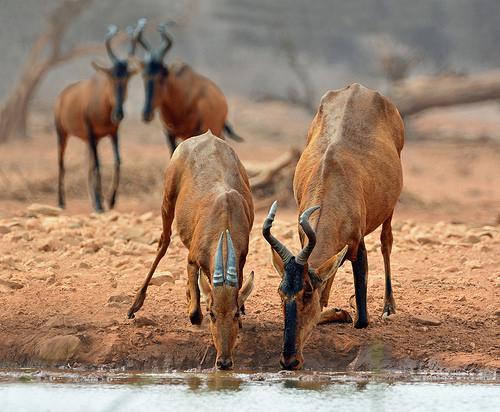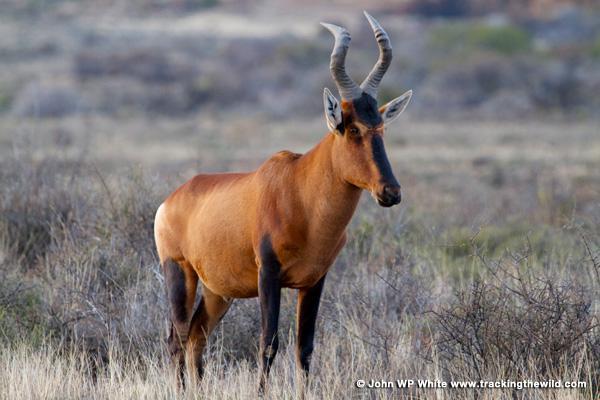The first image is the image on the left, the second image is the image on the right. For the images displayed, is the sentence "There are exactly two horned animals standing in total." factually correct? Answer yes or no. No. The first image is the image on the left, the second image is the image on the right. For the images shown, is this caption "In one of the images, there is an animal near water." true? Answer yes or no. Yes. 